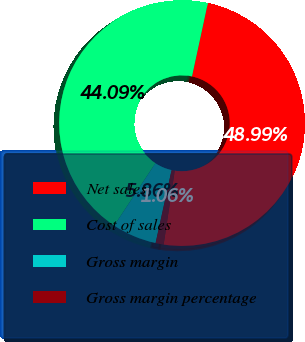Convert chart to OTSL. <chart><loc_0><loc_0><loc_500><loc_500><pie_chart><fcel>Net sales<fcel>Cost of sales<fcel>Gross margin<fcel>Gross margin percentage<nl><fcel>48.99%<fcel>44.09%<fcel>5.86%<fcel>1.06%<nl></chart> 